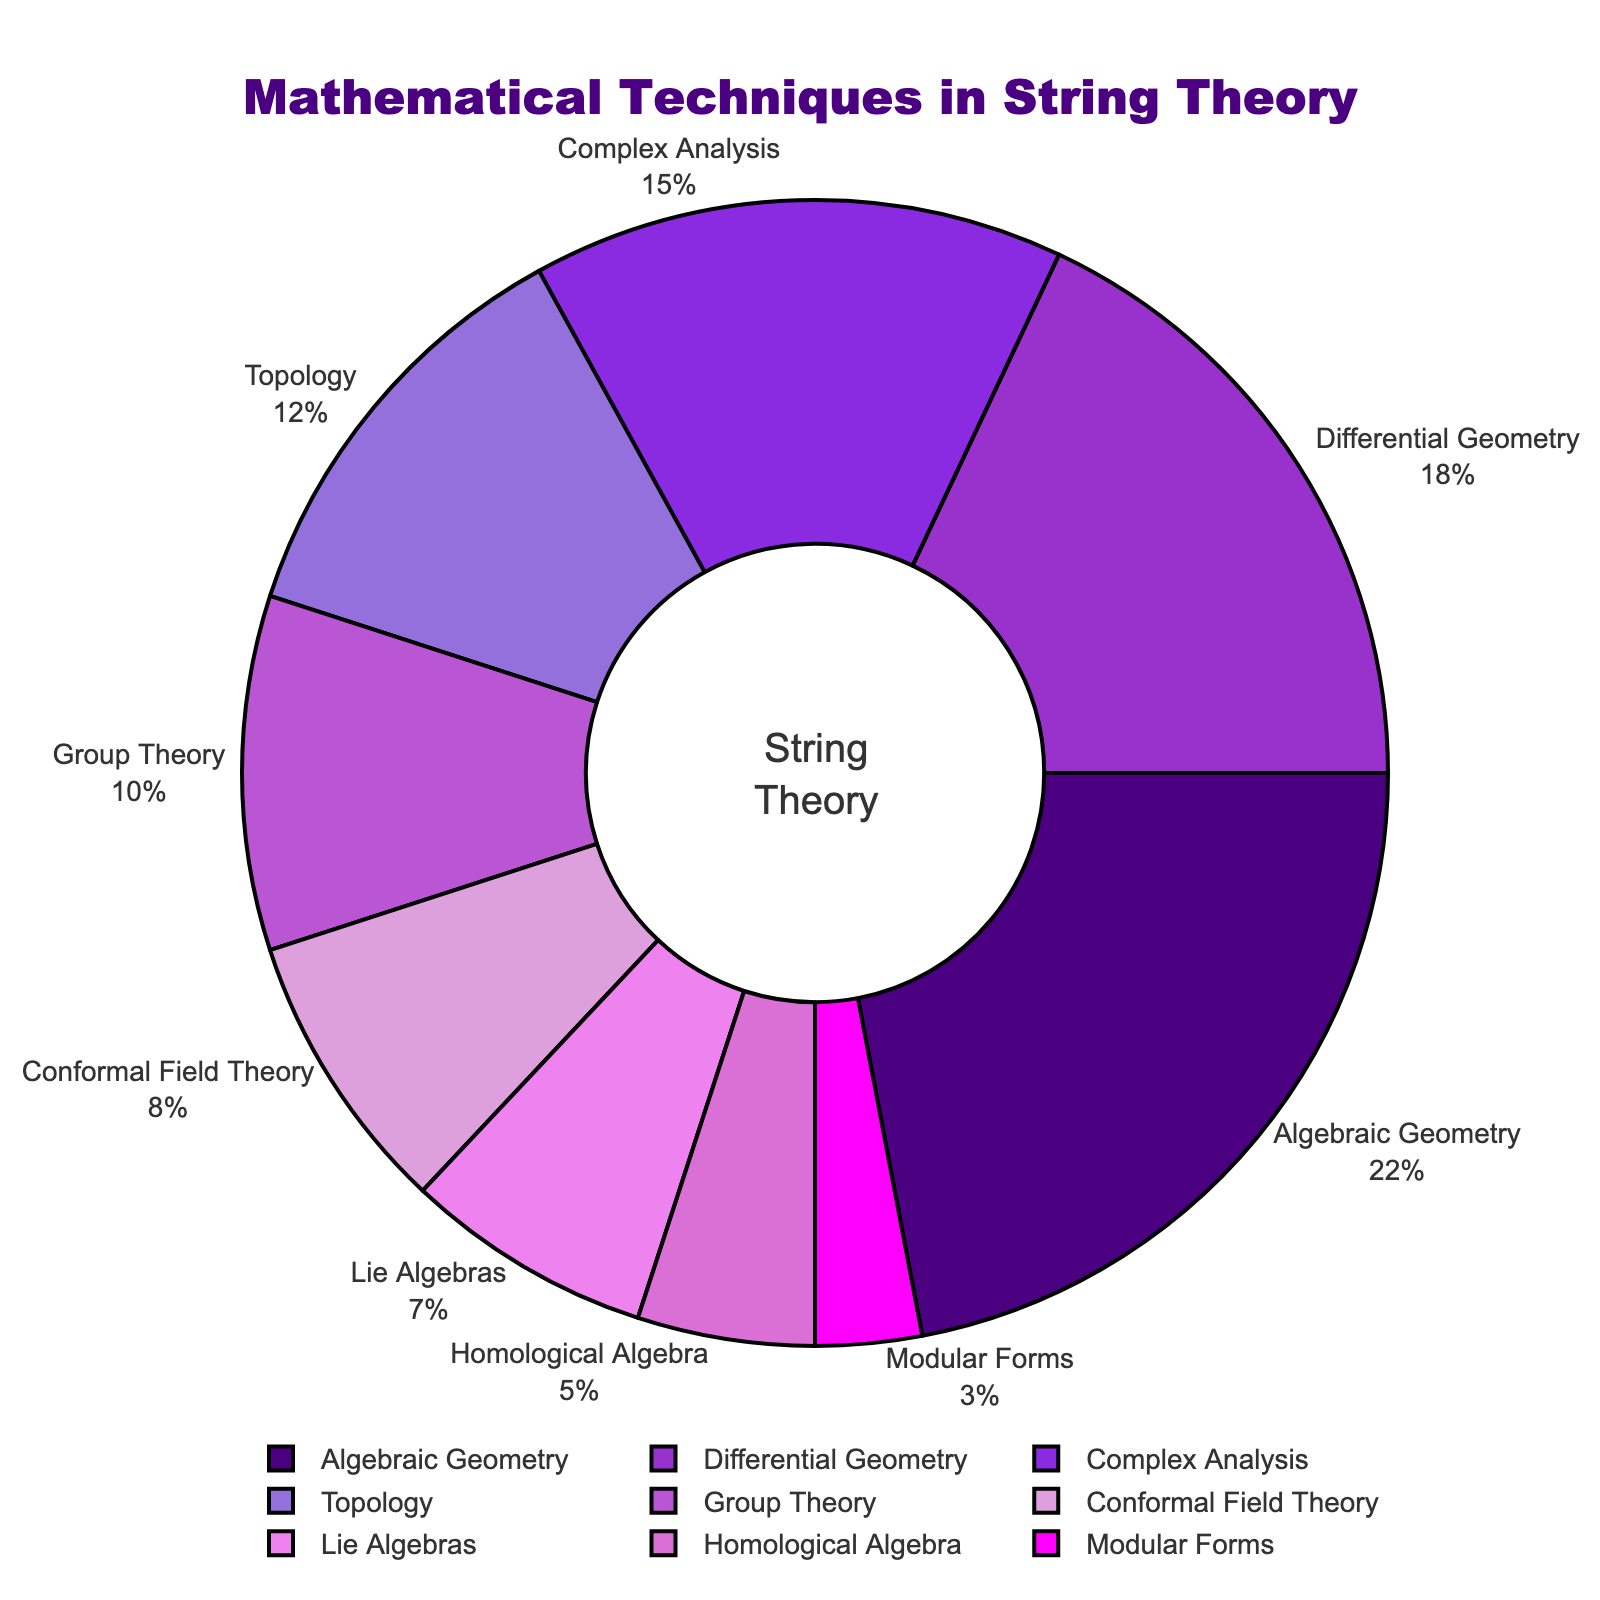What percentage of the total does Algebraic Geometry represent? To answer this, look at the figure and see that Algebraic Geometry occupies 22% of the total area.
Answer: 22% Which mathematical technique appears the least in string theory? Identify the section with the smallest percentage on the pie chart, which is Modular Forms at 3%.
Answer: Modular Forms What is the combined percentage of Differential Geometry and Complex Analysis? Combine the percentages of Differential Geometry (18%) and Complex Analysis (15%) by adding them together: 18% + 15% = 33%.
Answer: 33% Is Group Theory's percentage greater than or less than Homological Algebra's percentage? Compare the segment sizes for Group Theory at 10% and Homological Algebra at 5%. Group Theory is greater.
Answer: Greater By how much does the percentage of Topology exceed that of Modular Forms? Subtract Modular Forms' percentage (3%) from Topology's percentage (12%): 12% - 3% = 9%.
Answer: 9% Which mathematical technique has the largest slice next to Algebraic Geometry? Observe the pie chart and see that the next largest segment adjacent to Algebraic Geometry is Differential Geometry with 18%.
Answer: Differential Geometry How does the percentage of Conformal Field Theory compare to Lie Algebras? Compare the size of the sections; Conformal Field Theory is at 8%, and Lie Algebras are at 7%. Conformal Field Theory is greater.
Answer: Greater What is the combined percentage of the three least represented techniques? Sum the percentages of Modular Forms (3%), Homological Algebra (5%), and Lie Algebras (7%): 3% + 5% + 7% = 15%.
Answer: 15% What is the average percentage of the listed techniques? Add all percentages: 22% + 18% + 15% + 12% + 10% + 8% + 7% + 5% + 3% = 100%, then divide by the number of techniques (9): 100% / 9 ≈ 11.11%.
Answer: 11.11% What percentage do techniques other than Algebraic Geometry constitute? Subtract Algebraic Geometry's percentage from the total 100%: 100% - 22% = 78%.
Answer: 78% 